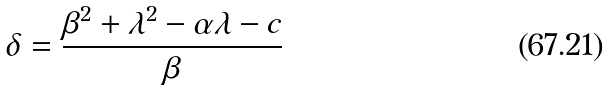<formula> <loc_0><loc_0><loc_500><loc_500>\delta = \frac { \beta ^ { 2 } + \lambda ^ { 2 } - \alpha \lambda - c } { \beta }</formula> 